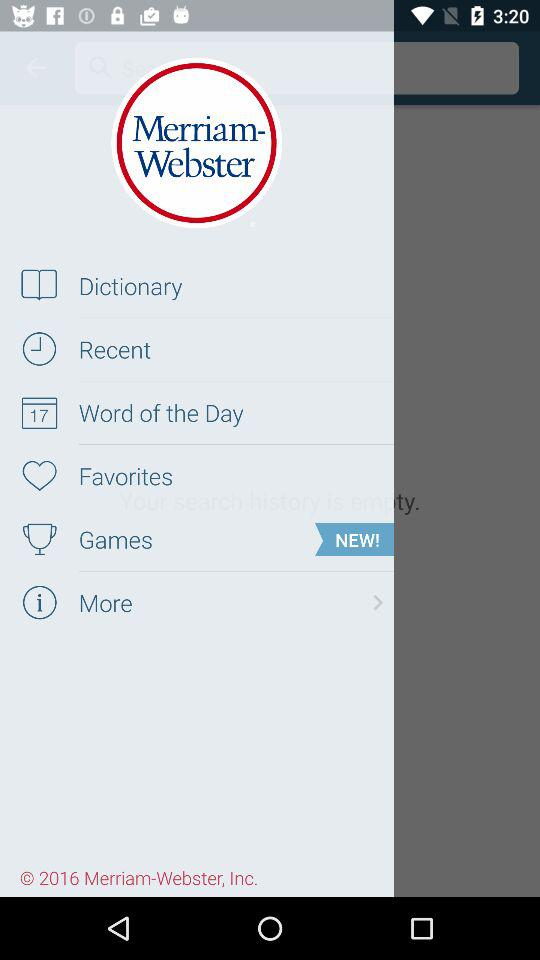What is the application name? The application name is "Merriam-Webster". 